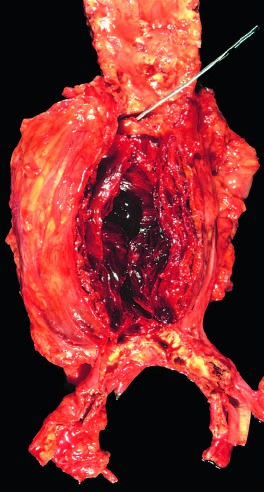what is the lumen filled by?
Answer the question using a single word or phrase. A large 